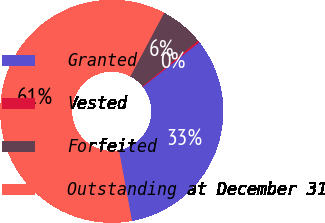<chart> <loc_0><loc_0><loc_500><loc_500><pie_chart><fcel>Granted<fcel>Vested<fcel>Forfeited<fcel>Outstanding at December 31<nl><fcel>32.73%<fcel>0.28%<fcel>6.32%<fcel>60.67%<nl></chart> 